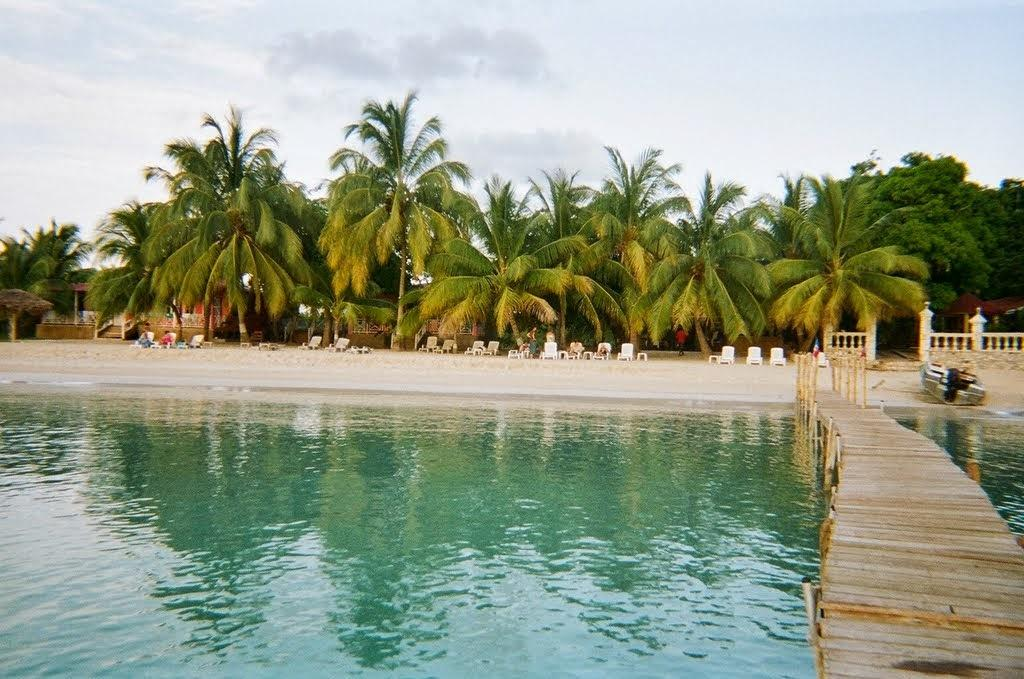What is the primary element visible in the image? There is water in the image. What type of structure can be seen in the image? There is a wooden bridge in the image. What is located near the water's edge in the image? There is a boat on the shore in the image. What type of furniture is present in the image? There are chairs in the image. What are the chairs being used for in the image? There are persons sitting on the chairs in the image. What can be seen in the background of the image? There are trees and the sky visible in the background of the image. What type of pig can be seen in the image? There is no pig present in the image. 